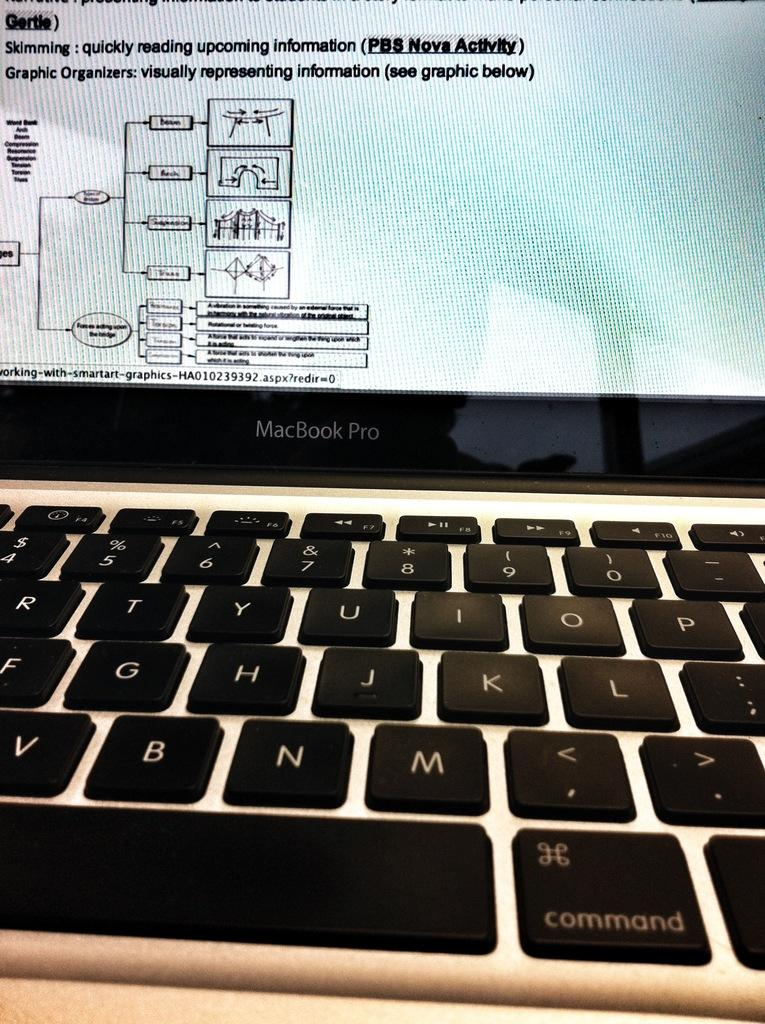<image>
Provide a brief description of the given image. A MacBook Pro has a diagram displayed on the screen. 